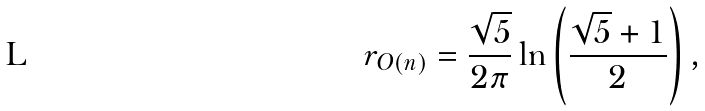Convert formula to latex. <formula><loc_0><loc_0><loc_500><loc_500>r _ { O ( n ) } = \frac { \sqrt { 5 } } { 2 \pi } \ln \left ( \frac { \sqrt { 5 } + 1 } { 2 } \right ) ,</formula> 